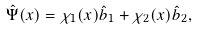Convert formula to latex. <formula><loc_0><loc_0><loc_500><loc_500>\hat { \Psi } ( { x } ) = \chi _ { 1 } ( { x } ) \hat { b } _ { 1 } + \chi _ { 2 } ( { x } ) \hat { b } _ { 2 } ,</formula> 